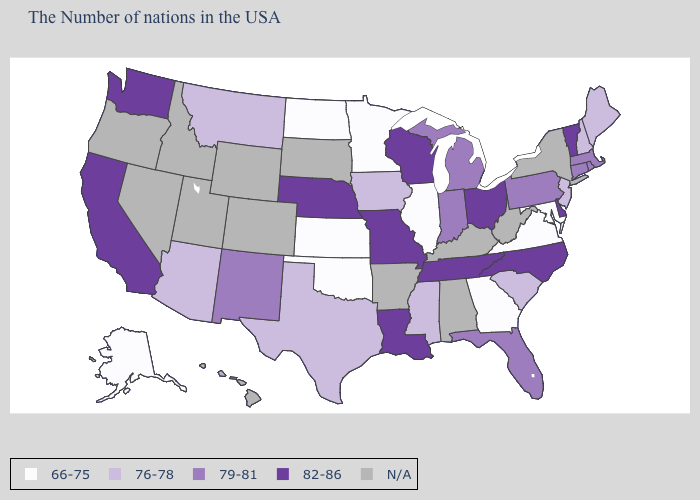What is the value of Maryland?
Give a very brief answer. 66-75. What is the highest value in states that border South Dakota?
Answer briefly. 82-86. What is the value of South Dakota?
Write a very short answer. N/A. What is the value of Hawaii?
Short answer required. N/A. Name the states that have a value in the range 79-81?
Concise answer only. Massachusetts, Rhode Island, Connecticut, Pennsylvania, Florida, Michigan, Indiana, New Mexico. Is the legend a continuous bar?
Answer briefly. No. Among the states that border Michigan , does Indiana have the highest value?
Concise answer only. No. Does the first symbol in the legend represent the smallest category?
Quick response, please. Yes. How many symbols are there in the legend?
Answer briefly. 5. What is the value of Kentucky?
Quick response, please. N/A. What is the highest value in the USA?
Concise answer only. 82-86. What is the lowest value in the USA?
Keep it brief. 66-75. Does Wisconsin have the highest value in the USA?
Give a very brief answer. Yes. Which states hav the highest value in the West?
Write a very short answer. California, Washington. What is the value of Indiana?
Write a very short answer. 79-81. 